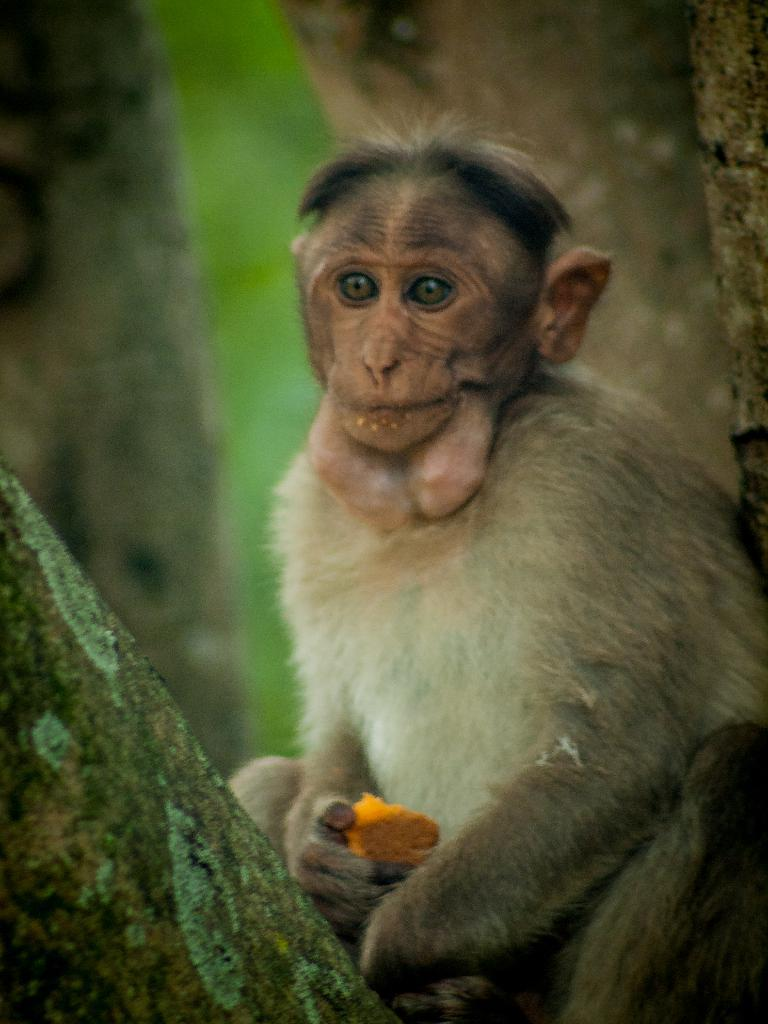What animal is present in the image? There is a monkey in the image. What is the monkey doing in the image? The monkey is sitting in the image. What is the monkey holding in the image? The monkey is holding an object in the image. What type of natural feature can be seen in the image? There are tree trunks in the image. How would you describe the background of the image? The background of the image is blurred. What type of trousers is the monkey wearing in the image? Monkeys do not wear trousers, so this detail cannot be found in the image. 